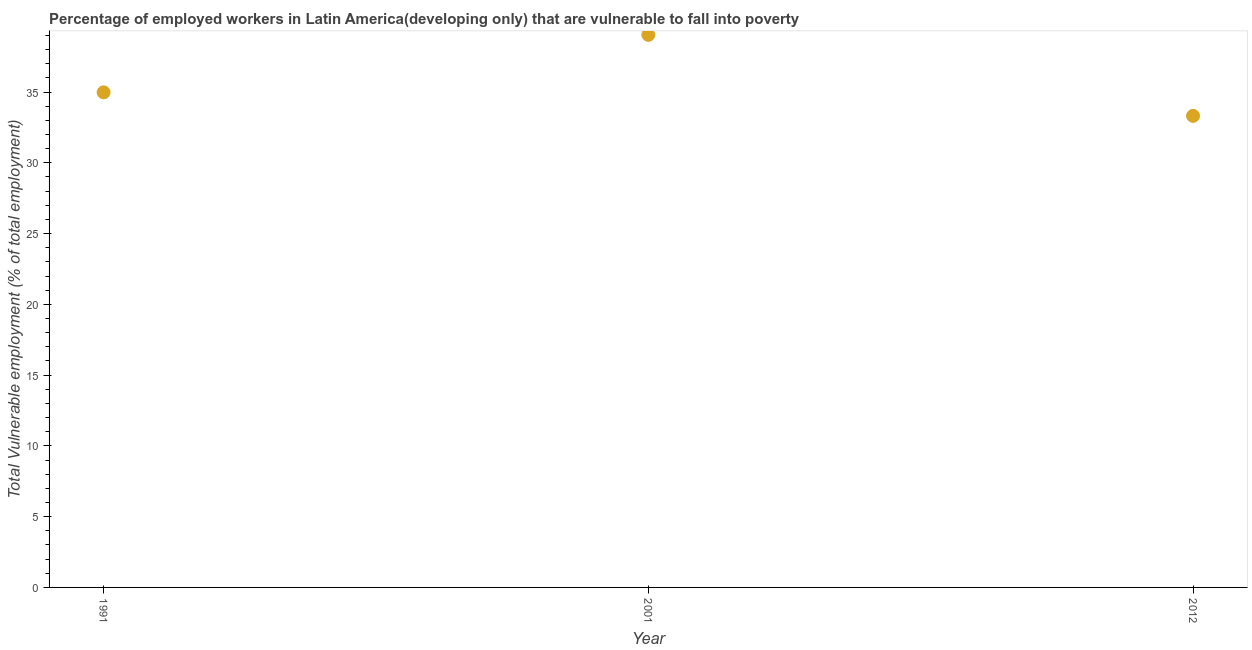What is the total vulnerable employment in 2012?
Provide a short and direct response. 33.32. Across all years, what is the maximum total vulnerable employment?
Your answer should be compact. 39.04. Across all years, what is the minimum total vulnerable employment?
Your answer should be very brief. 33.32. In which year was the total vulnerable employment maximum?
Make the answer very short. 2001. What is the sum of the total vulnerable employment?
Your answer should be very brief. 107.34. What is the difference between the total vulnerable employment in 1991 and 2001?
Your answer should be very brief. -4.06. What is the average total vulnerable employment per year?
Provide a succinct answer. 35.78. What is the median total vulnerable employment?
Your response must be concise. 34.98. In how many years, is the total vulnerable employment greater than 9 %?
Give a very brief answer. 3. What is the ratio of the total vulnerable employment in 1991 to that in 2001?
Make the answer very short. 0.9. Is the total vulnerable employment in 1991 less than that in 2001?
Make the answer very short. Yes. Is the difference between the total vulnerable employment in 2001 and 2012 greater than the difference between any two years?
Your response must be concise. Yes. What is the difference between the highest and the second highest total vulnerable employment?
Give a very brief answer. 4.06. Is the sum of the total vulnerable employment in 2001 and 2012 greater than the maximum total vulnerable employment across all years?
Your answer should be very brief. Yes. What is the difference between the highest and the lowest total vulnerable employment?
Your response must be concise. 5.72. In how many years, is the total vulnerable employment greater than the average total vulnerable employment taken over all years?
Keep it short and to the point. 1. How many years are there in the graph?
Ensure brevity in your answer.  3. Are the values on the major ticks of Y-axis written in scientific E-notation?
Make the answer very short. No. What is the title of the graph?
Provide a short and direct response. Percentage of employed workers in Latin America(developing only) that are vulnerable to fall into poverty. What is the label or title of the X-axis?
Offer a very short reply. Year. What is the label or title of the Y-axis?
Offer a terse response. Total Vulnerable employment (% of total employment). What is the Total Vulnerable employment (% of total employment) in 1991?
Provide a succinct answer. 34.98. What is the Total Vulnerable employment (% of total employment) in 2001?
Make the answer very short. 39.04. What is the Total Vulnerable employment (% of total employment) in 2012?
Your answer should be very brief. 33.32. What is the difference between the Total Vulnerable employment (% of total employment) in 1991 and 2001?
Your answer should be compact. -4.06. What is the difference between the Total Vulnerable employment (% of total employment) in 1991 and 2012?
Ensure brevity in your answer.  1.66. What is the difference between the Total Vulnerable employment (% of total employment) in 2001 and 2012?
Your answer should be compact. 5.72. What is the ratio of the Total Vulnerable employment (% of total employment) in 1991 to that in 2001?
Offer a terse response. 0.9. What is the ratio of the Total Vulnerable employment (% of total employment) in 2001 to that in 2012?
Give a very brief answer. 1.17. 